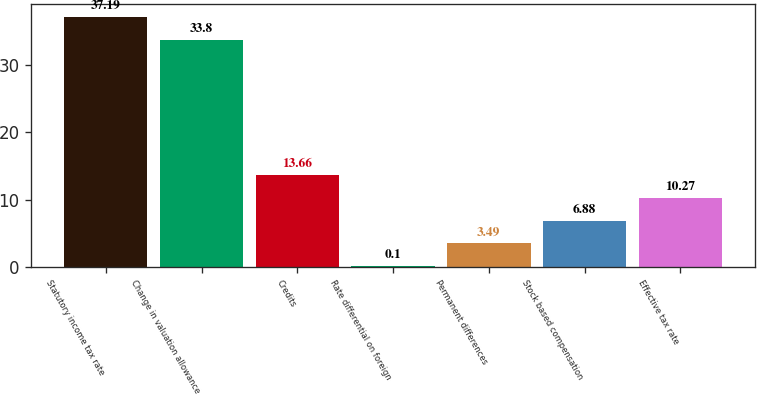<chart> <loc_0><loc_0><loc_500><loc_500><bar_chart><fcel>Statutory income tax rate<fcel>Change in valuation allowance<fcel>Credits<fcel>Rate differential on foreign<fcel>Permanent differences<fcel>Stock based compensation<fcel>Effective tax rate<nl><fcel>37.19<fcel>33.8<fcel>13.66<fcel>0.1<fcel>3.49<fcel>6.88<fcel>10.27<nl></chart> 